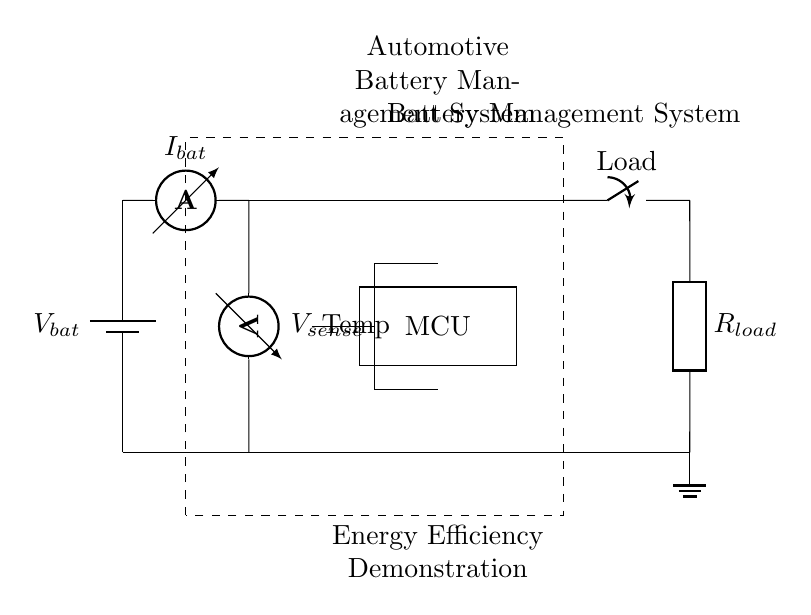What is the main function of the dashed rectangle? The dashed rectangle represents the Battery Management System, which typically controls various aspects of the battery's operation, including its charging and discharging cycles.
Answer: Battery Management System What type of sensor is indicated by the component near the middle of the circuit? The component labeled "Temp" is a thermistor, which is a type of temperature sensor used to monitor the battery's temperature to ensure safe operating conditions.
Answer: Thermistor How many main connections are there from the battery to the load? There are four main connections in a sequential path from the battery to the load, with additional connections for sensors and the microcontroller.
Answer: Four What does the current sensor measure? The current sensor labeled as "I_bat" measures the current flowing from the battery, providing critical data for the management of battery performance.
Answer: Current What is the role of the microcontroller in this circuit? The microcontroller, labeled "MCU," processes information from the sensors and controls the operation of the load switch based on that information, optimizing energy usage.
Answer: Control How is the load connected in relation to the battery? The load is connected in series with the battery, meaning that the current must pass through the load after leaving the battery and before returning to ground.
Answer: Series 